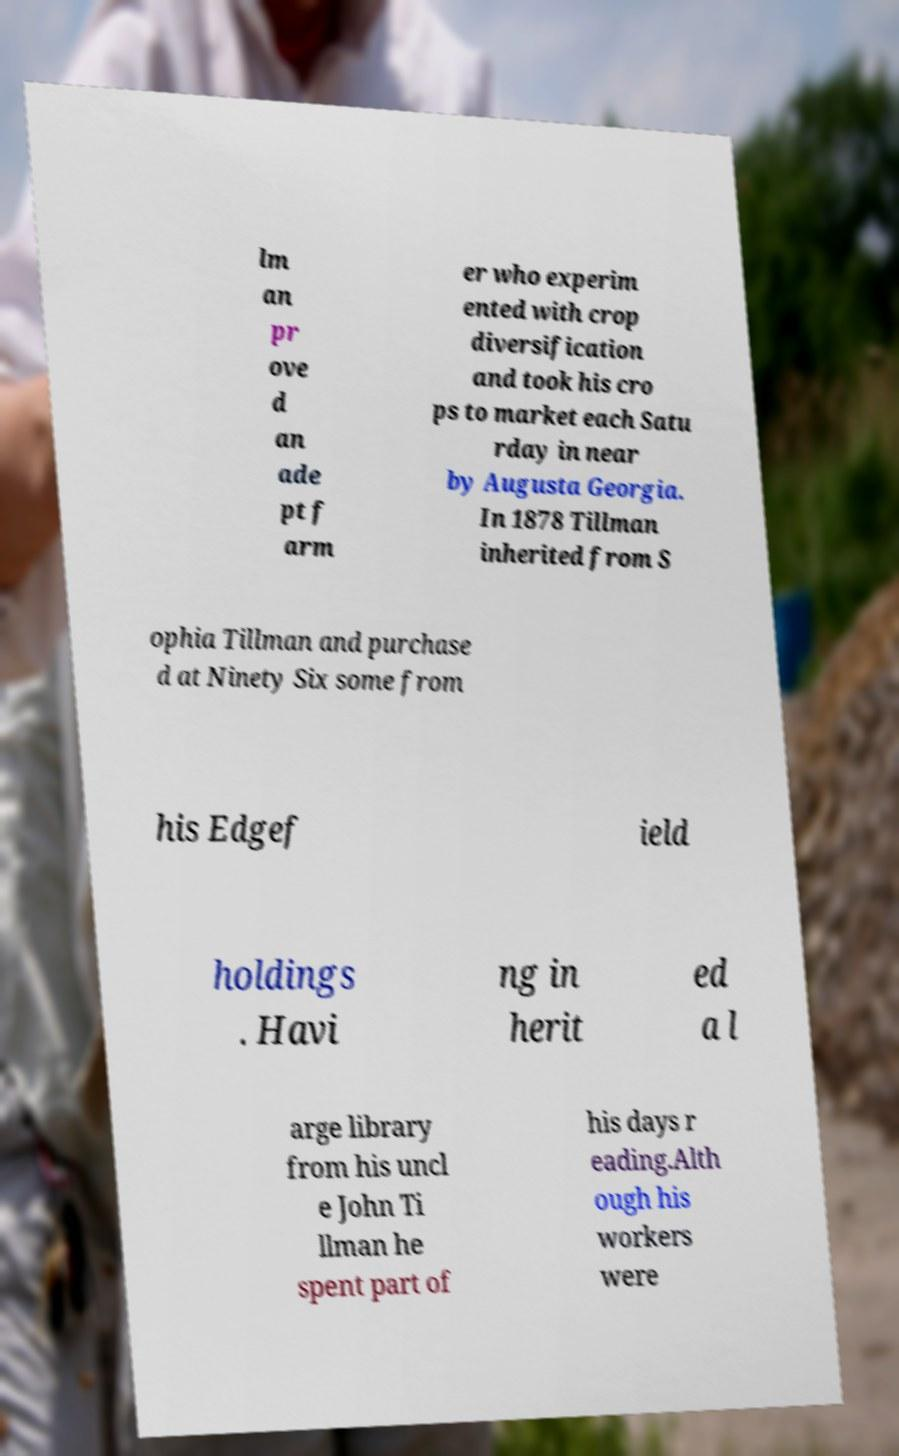Can you accurately transcribe the text from the provided image for me? lm an pr ove d an ade pt f arm er who experim ented with crop diversification and took his cro ps to market each Satu rday in near by Augusta Georgia. In 1878 Tillman inherited from S ophia Tillman and purchase d at Ninety Six some from his Edgef ield holdings . Havi ng in herit ed a l arge library from his uncl e John Ti llman he spent part of his days r eading.Alth ough his workers were 